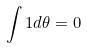<formula> <loc_0><loc_0><loc_500><loc_500>\int 1 d \theta = 0</formula> 